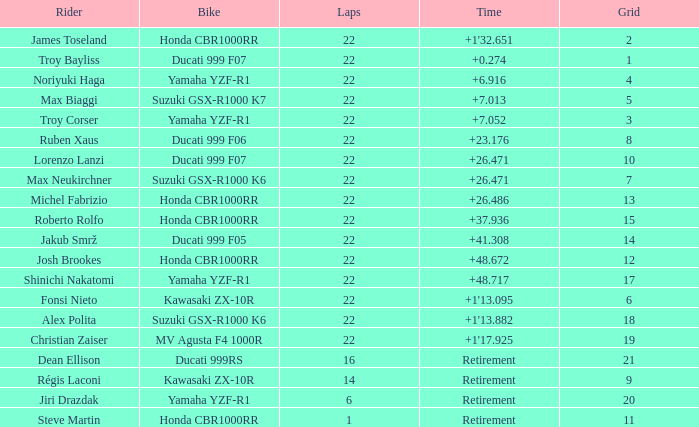Which bike did Jiri Drazdak ride when he had a grid number larger than 14 and less than 22 laps? Yamaha YZF-R1. 